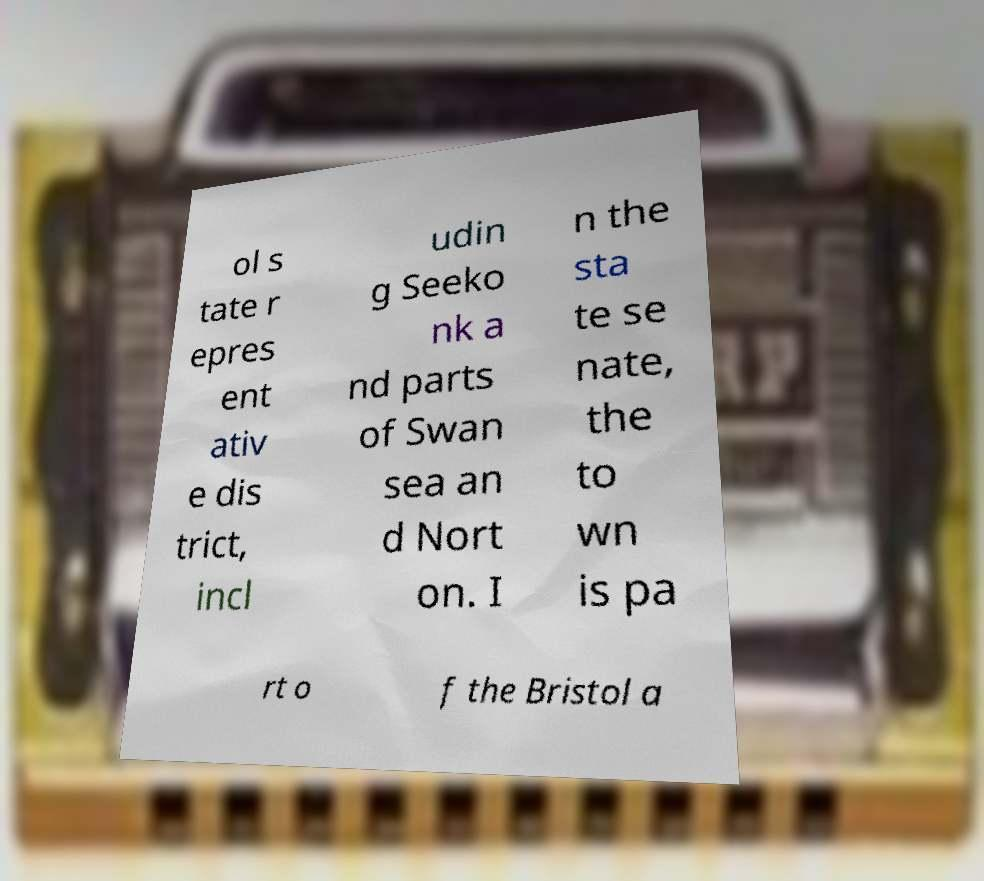Can you read and provide the text displayed in the image?This photo seems to have some interesting text. Can you extract and type it out for me? ol s tate r epres ent ativ e dis trict, incl udin g Seeko nk a nd parts of Swan sea an d Nort on. I n the sta te se nate, the to wn is pa rt o f the Bristol a 